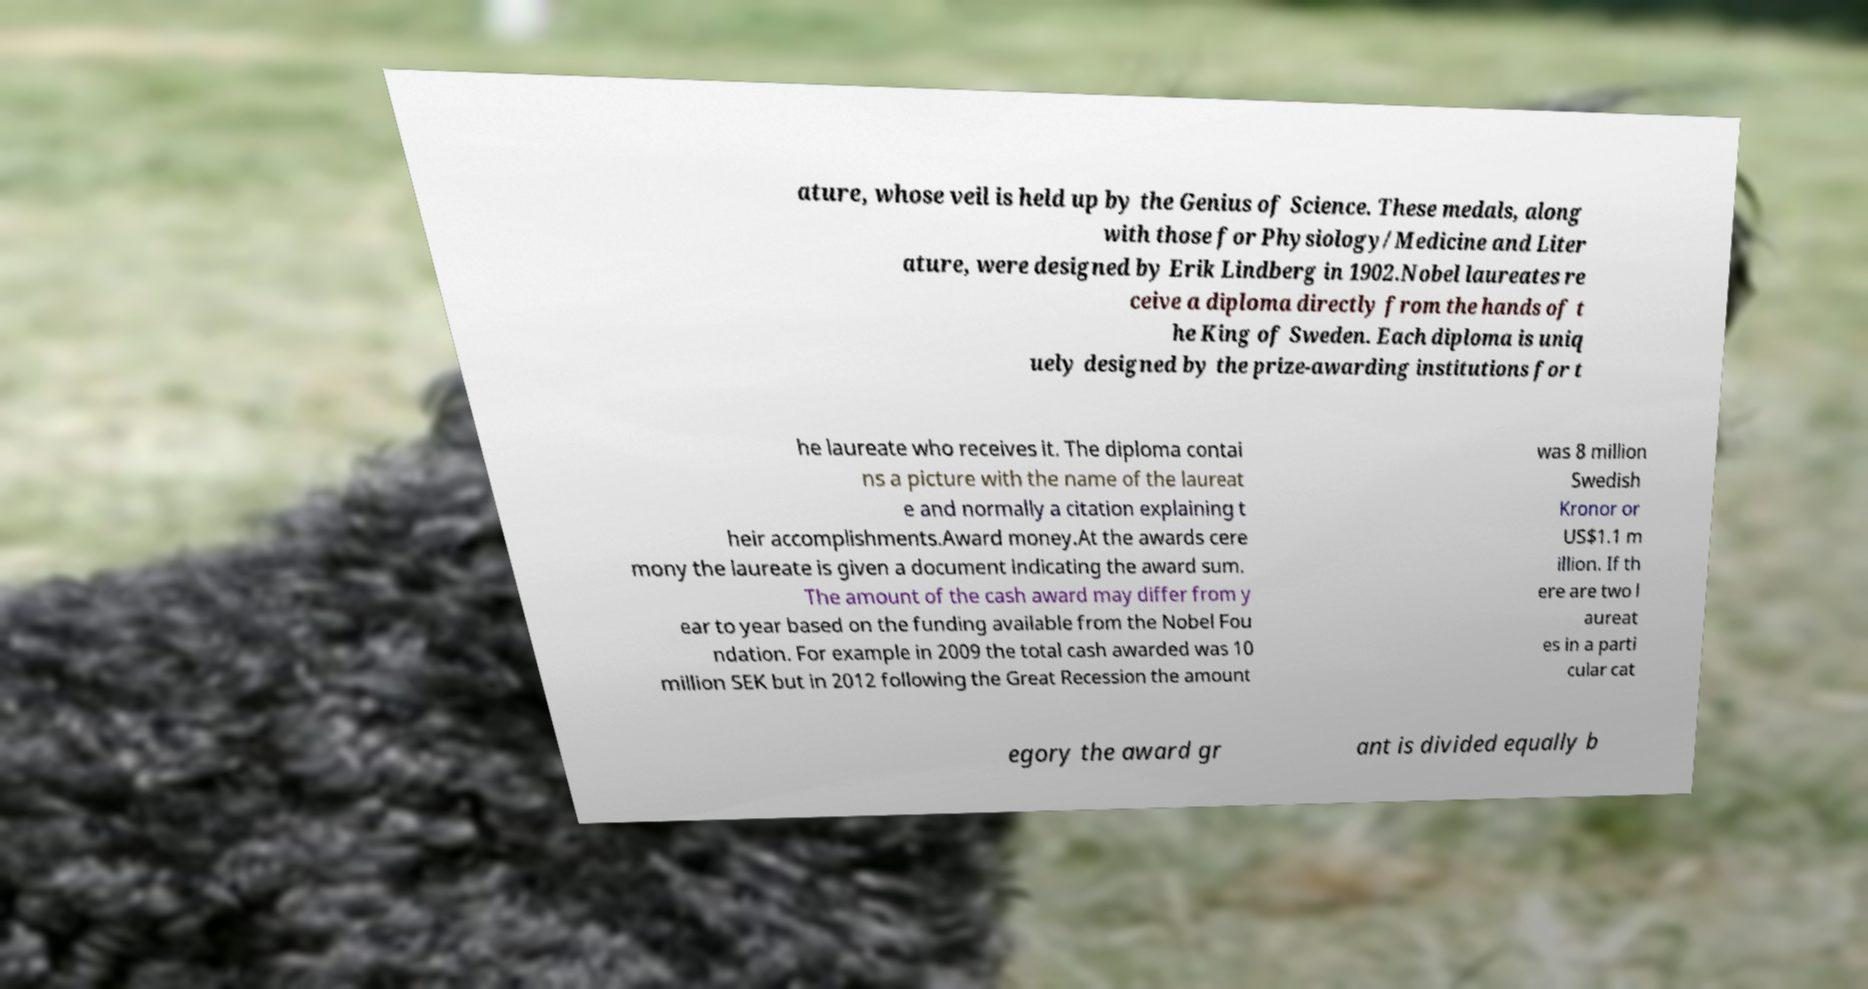Please identify and transcribe the text found in this image. ature, whose veil is held up by the Genius of Science. These medals, along with those for Physiology/Medicine and Liter ature, were designed by Erik Lindberg in 1902.Nobel laureates re ceive a diploma directly from the hands of t he King of Sweden. Each diploma is uniq uely designed by the prize-awarding institutions for t he laureate who receives it. The diploma contai ns a picture with the name of the laureat e and normally a citation explaining t heir accomplishments.Award money.At the awards cere mony the laureate is given a document indicating the award sum. The amount of the cash award may differ from y ear to year based on the funding available from the Nobel Fou ndation. For example in 2009 the total cash awarded was 10 million SEK but in 2012 following the Great Recession the amount was 8 million Swedish Kronor or US$1.1 m illion. If th ere are two l aureat es in a parti cular cat egory the award gr ant is divided equally b 